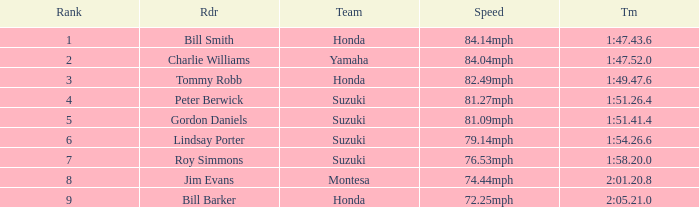What was the time for Peter Berwick of Team Suzuki? 1:51.26.4. 